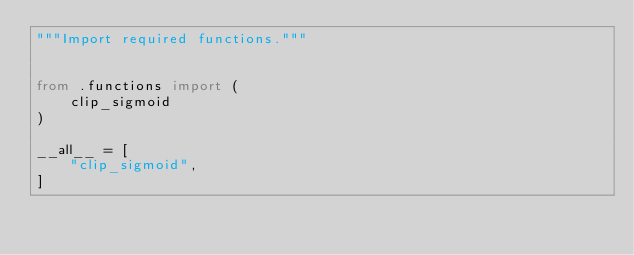Convert code to text. <code><loc_0><loc_0><loc_500><loc_500><_Python_>"""Import required functions."""


from .functions import (
    clip_sigmoid
)

__all__ = [
    "clip_sigmoid",
]
</code> 